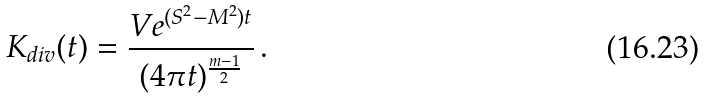Convert formula to latex. <formula><loc_0><loc_0><loc_500><loc_500>K _ { d i v } ( t ) = \frac { V e ^ { ( S ^ { 2 } - M ^ { 2 } ) t } } { ( 4 \pi t ) ^ { \frac { m - 1 } 2 } } \, .</formula> 